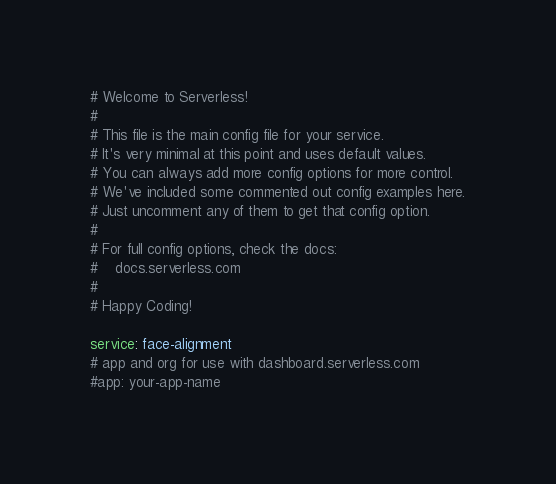<code> <loc_0><loc_0><loc_500><loc_500><_YAML_># Welcome to Serverless!
#
# This file is the main config file for your service.
# It's very minimal at this point and uses default values.
# You can always add more config options for more control.
# We've included some commented out config examples here.
# Just uncomment any of them to get that config option.
#
# For full config options, check the docs:
#    docs.serverless.com
#
# Happy Coding!

service: face-alignment
# app and org for use with dashboard.serverless.com
#app: your-app-name</code> 